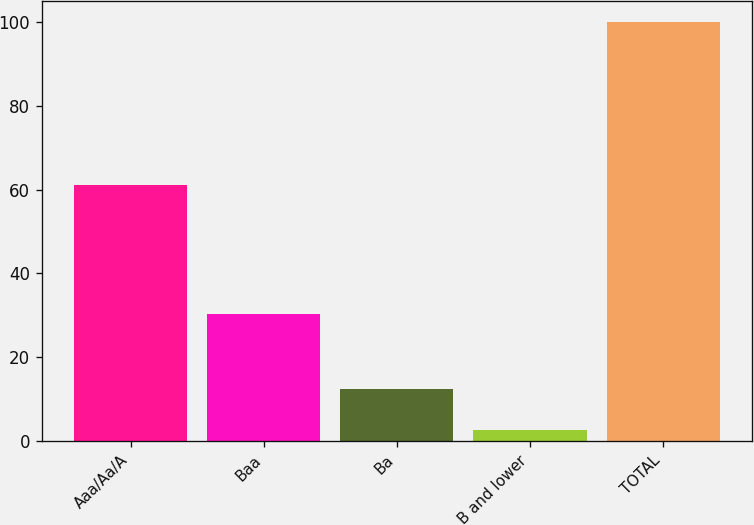Convert chart to OTSL. <chart><loc_0><loc_0><loc_500><loc_500><bar_chart><fcel>Aaa/Aa/A<fcel>Baa<fcel>Ba<fcel>B and lower<fcel>TOTAL<nl><fcel>61.2<fcel>30.4<fcel>12.34<fcel>2.6<fcel>100<nl></chart> 